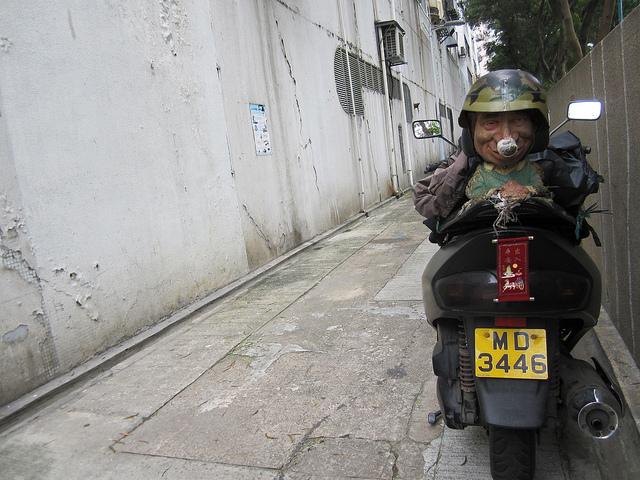What type of vehicle is in the picture?
Give a very brief answer. Motorcycle. What does the tag say?
Quick response, please. Md 3446. Is that person real?
Concise answer only. No. What numbers are displayed on the front of the bike?
Answer briefly. 3446. 